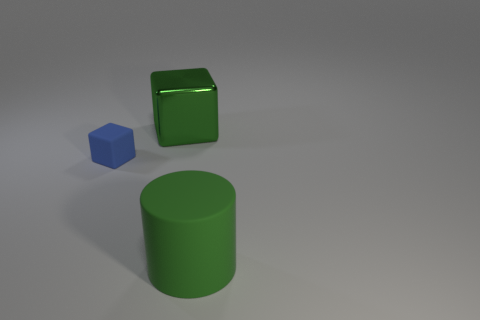Does the rubber cylinder have the same color as the metal cube?
Provide a short and direct response. Yes. What color is the big object that is made of the same material as the blue cube?
Keep it short and to the point. Green. The large matte thing is what shape?
Provide a succinct answer. Cylinder. There is a large green thing that is in front of the big cube; what is its material?
Your answer should be very brief. Rubber. Is there a big cylinder of the same color as the small block?
Offer a terse response. No. There is a green thing that is the same size as the green block; what shape is it?
Provide a short and direct response. Cylinder. The large thing to the left of the big green matte cylinder is what color?
Offer a terse response. Green. Is there a big object that is on the left side of the large green thing in front of the tiny cube?
Ensure brevity in your answer.  Yes. How many things are large green things that are in front of the big metallic thing or green blocks?
Your response must be concise. 2. Is there any other thing that is the same size as the rubber block?
Provide a short and direct response. No. 